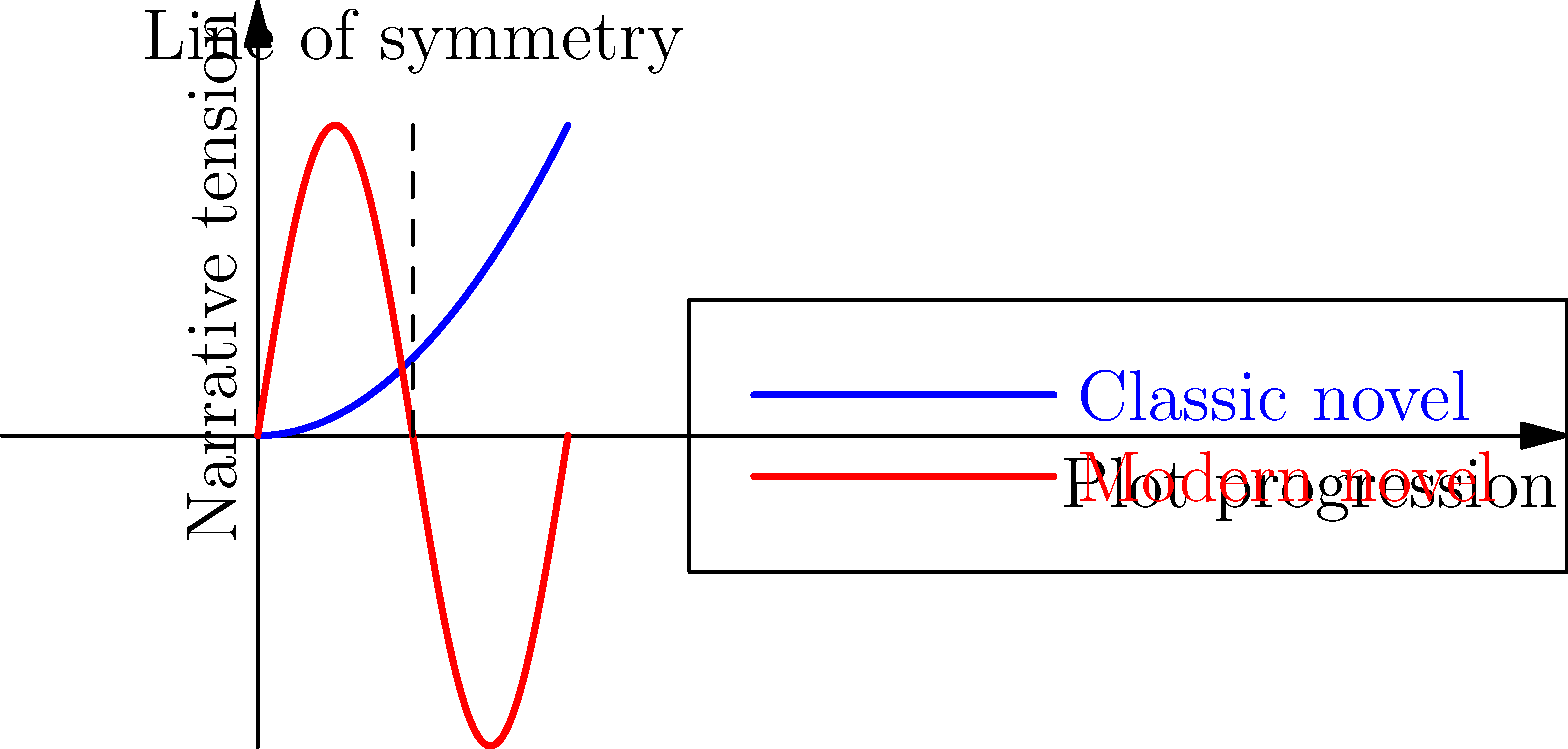The graph above represents the plot structures of a classic novel (blue curve) and a modern novel (red curve). If we apply a reflection transformation to the modern novel's plot structure about the vertical line x = 1, what would be the resulting function g'(x) in terms of g(x)? To solve this problem, we need to understand the concept of reflection in transformational geometry and apply it to the given function.

Step 1: Identify the original function
The original function for the modern novel's plot structure is g(x) = 2sin(πx).

Step 2: Understand the reflection transformation
A reflection about the vertical line x = 1 means that every point (x, y) on the original curve will be transformed to a point (x', y) where x' = 2 - x.

Step 3: Apply the transformation to the function
To reflect g(x) about x = 1, we replace every x in the original function with (2 - x):
g'(x) = 2sin(π(2 - x))

Step 4: Simplify using trigonometric identities
We can simplify this further using the trigonometric identity:
sin(A - B) = sin(A)cos(B) - cos(A)sin(B)

In our case, A = 2π and B = πx:
g'(x) = 2sin(2π - πx)
      = 2[sin(2π)cos(πx) - cos(2π)sin(πx)]
      = 2[-sin(πx)] (since sin(2π) = 0 and cos(2π) = 1)
      = -2sin(πx)

Step 5: Express g'(x) in terms of g(x)
Since g(x) = 2sin(πx), we can express g'(x) as:
g'(x) = -g(x)

This means that the reflected plot structure is the negative of the original function.
Answer: g'(x) = -g(x) 